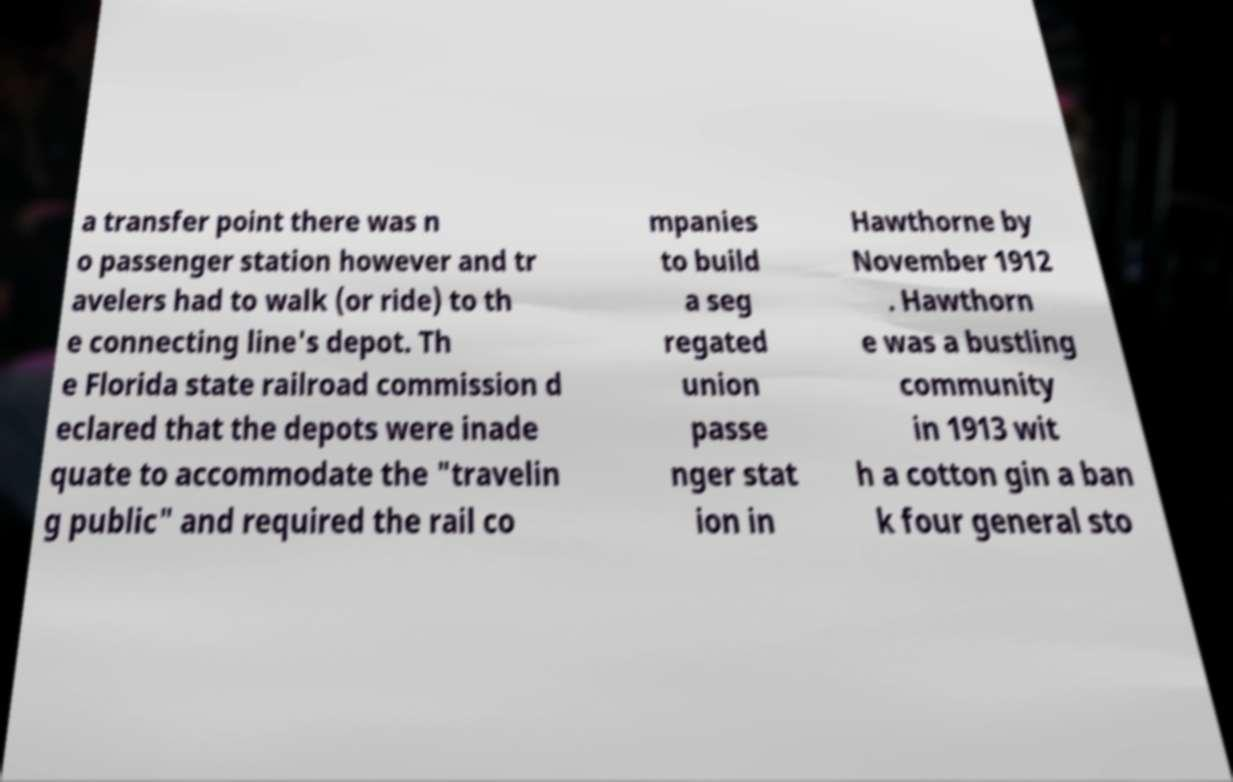Can you read and provide the text displayed in the image?This photo seems to have some interesting text. Can you extract and type it out for me? a transfer point there was n o passenger station however and tr avelers had to walk (or ride) to th e connecting line's depot. Th e Florida state railroad commission d eclared that the depots were inade quate to accommodate the "travelin g public" and required the rail co mpanies to build a seg regated union passe nger stat ion in Hawthorne by November 1912 . Hawthorn e was a bustling community in 1913 wit h a cotton gin a ban k four general sto 